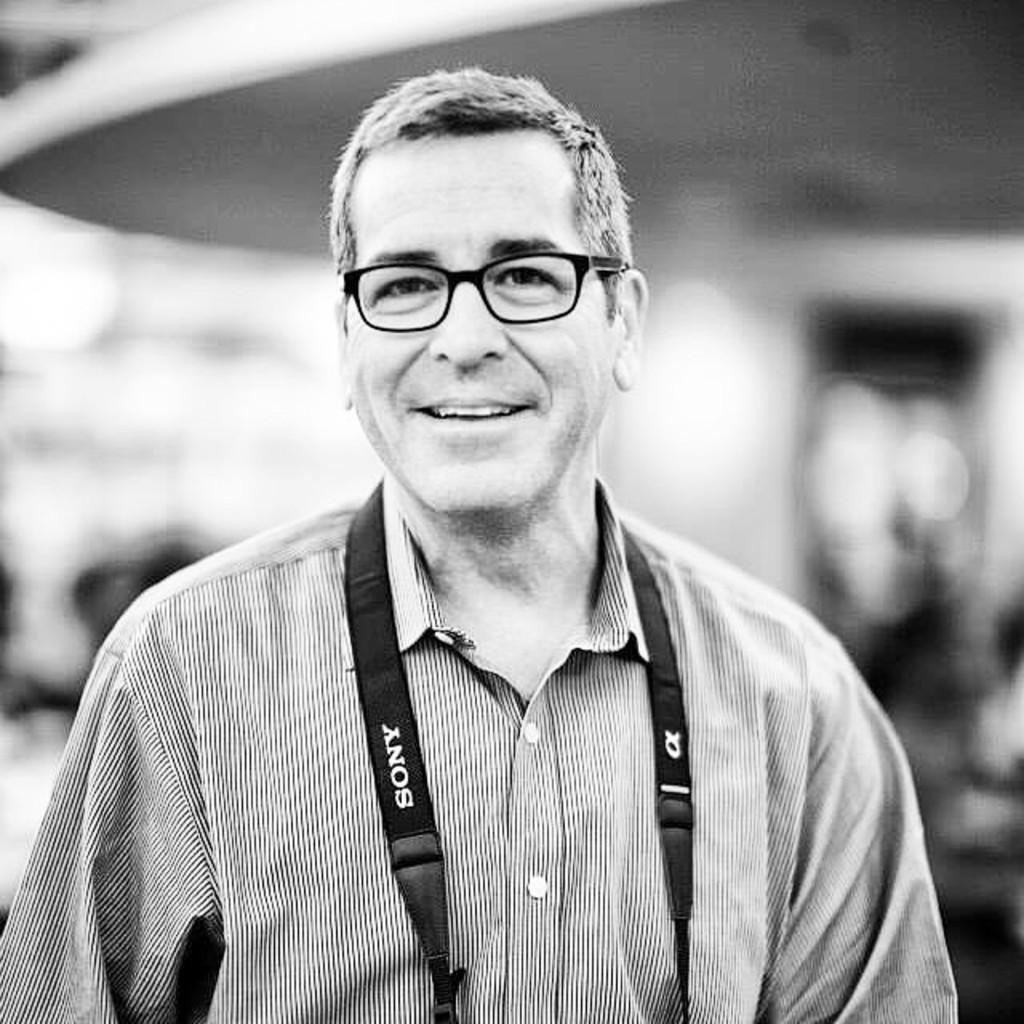What is the color scheme of the image? The image is black and white. Who is present in the image? There is a man in the image. What is the man wearing? The man is wearing a shirt and spectacles. What is the man holding in the image? The man is holding a camera. What is the man's facial expression? The man is smiling. How would you describe the background of the image? The background of the image is blurred. How many tomatoes can be seen in the image? There are no tomatoes present in the image. Is the man in the image smoking a pipe? There is no pipe visible in the image. 